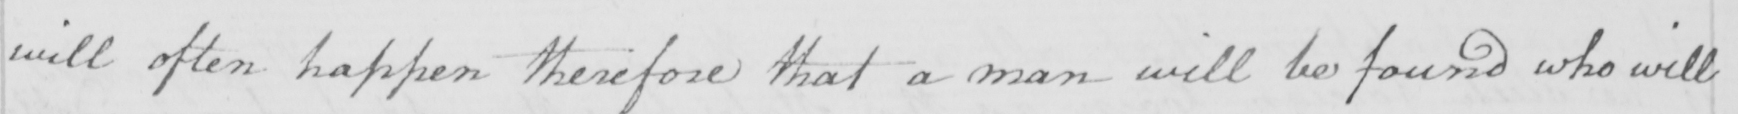What text is written in this handwritten line? will often happen therefore that a man will be found who will 